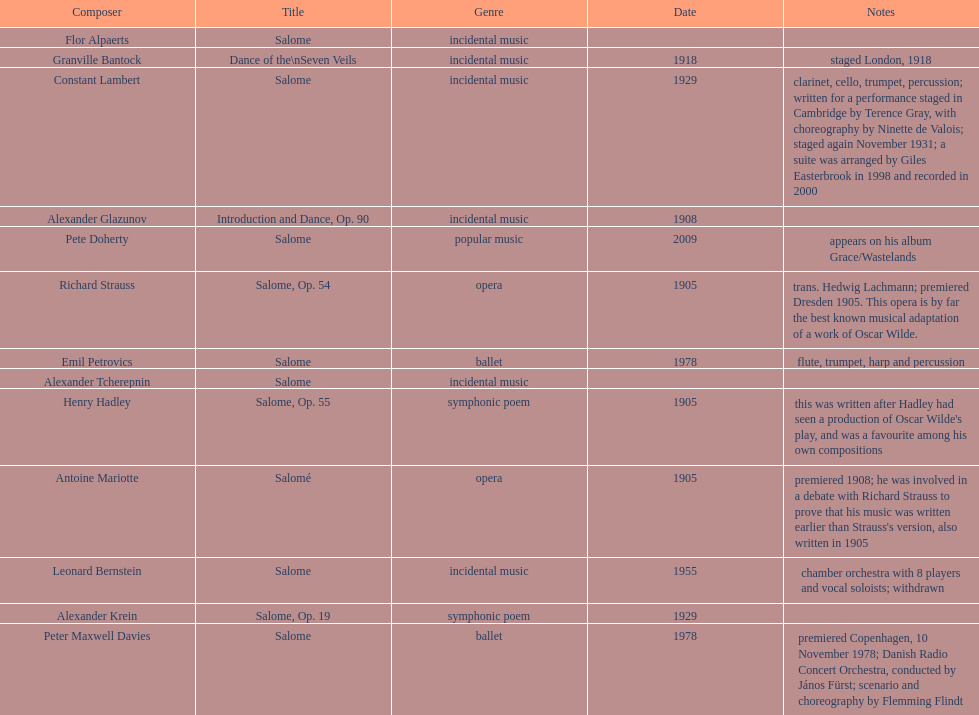How many are symphonic poems? 2. 